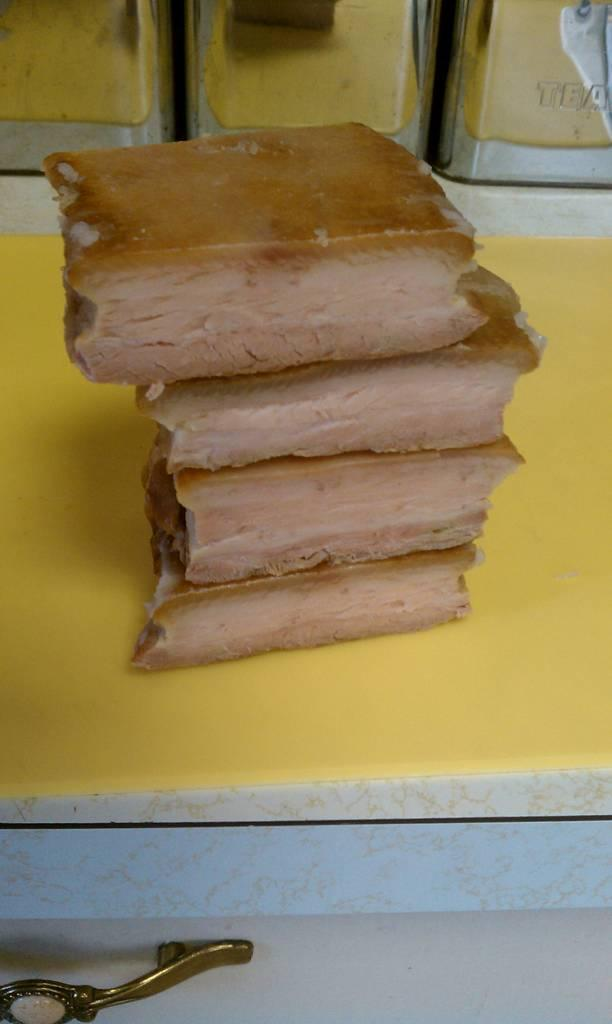What type of food is visible in the image? There is bread in the image. Where is the bread located? The bread is placed on a table. What is the head of the bread doing in the image? There is no head of the bread, as bread is a food item and does not have a head. 